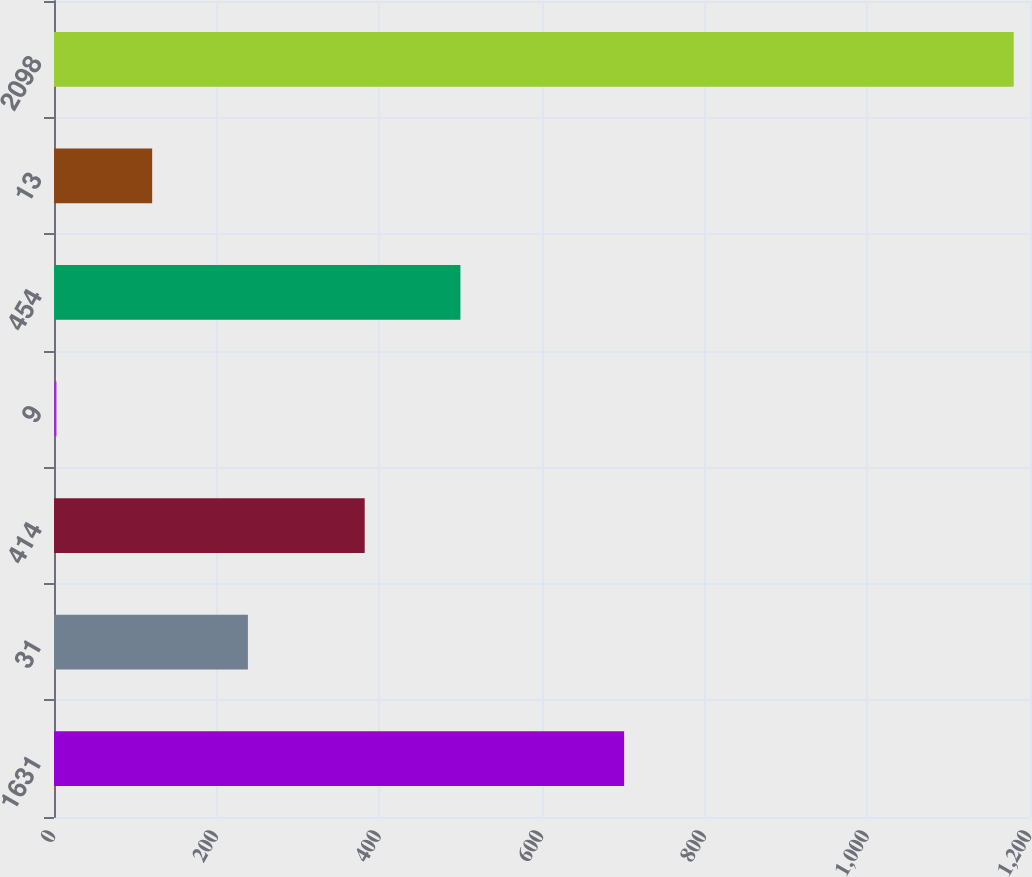Convert chart to OTSL. <chart><loc_0><loc_0><loc_500><loc_500><bar_chart><fcel>1631<fcel>31<fcel>414<fcel>9<fcel>454<fcel>13<fcel>2098<nl><fcel>701<fcel>238.4<fcel>382<fcel>3<fcel>499.7<fcel>120.7<fcel>1180<nl></chart> 